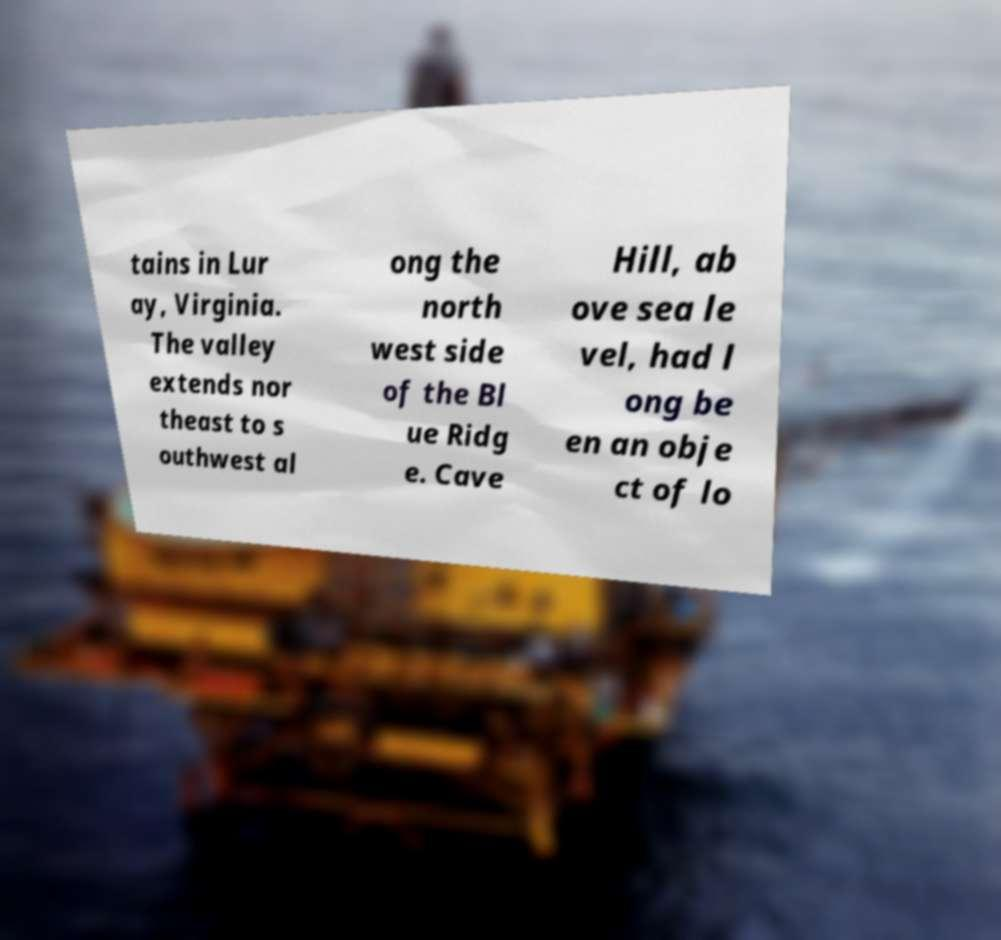Can you accurately transcribe the text from the provided image for me? tains in Lur ay, Virginia. The valley extends nor theast to s outhwest al ong the north west side of the Bl ue Ridg e. Cave Hill, ab ove sea le vel, had l ong be en an obje ct of lo 